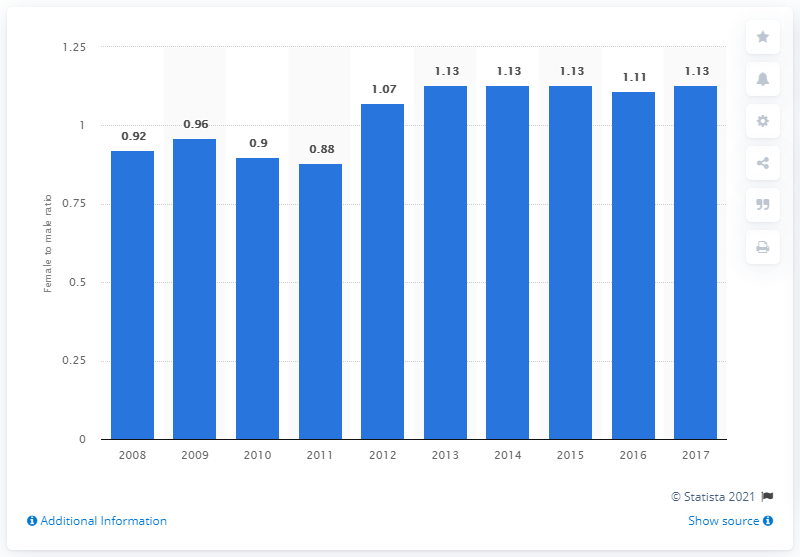Indicate a few pertinent items in this graphic. In 2017, the ratio of females to males in tertiary education in Indonesia was 1.13, indicating a slight female dominance in tertiary education. In 2017, there was a significant change in the female-to-male ratio in tertiary education in Indonesia. In 2008, there were 0.92 females for every 1 male enrolled in tertiary education in Indonesia. 